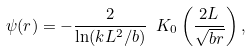Convert formula to latex. <formula><loc_0><loc_0><loc_500><loc_500>\psi ( r ) = - \frac { 2 } { \ln ( k L ^ { 2 } / b ) } \ K _ { 0 } \left ( \frac { 2 L } { \sqrt { b r } } \right ) ,</formula> 